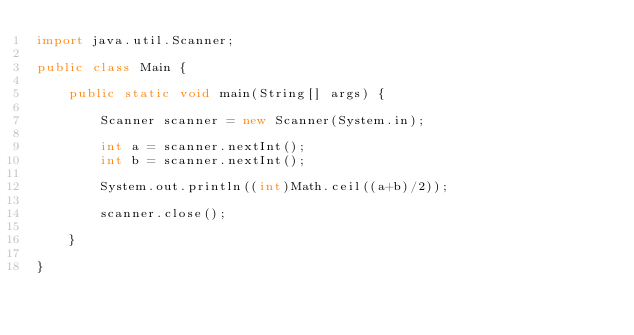Convert code to text. <code><loc_0><loc_0><loc_500><loc_500><_Java_>import java.util.Scanner;

public class Main {

	public static void main(String[] args) {

		Scanner scanner = new Scanner(System.in);

		int a = scanner.nextInt();
		int b = scanner.nextInt();

		System.out.println((int)Math.ceil((a+b)/2));

		scanner.close();

	}

}
</code> 